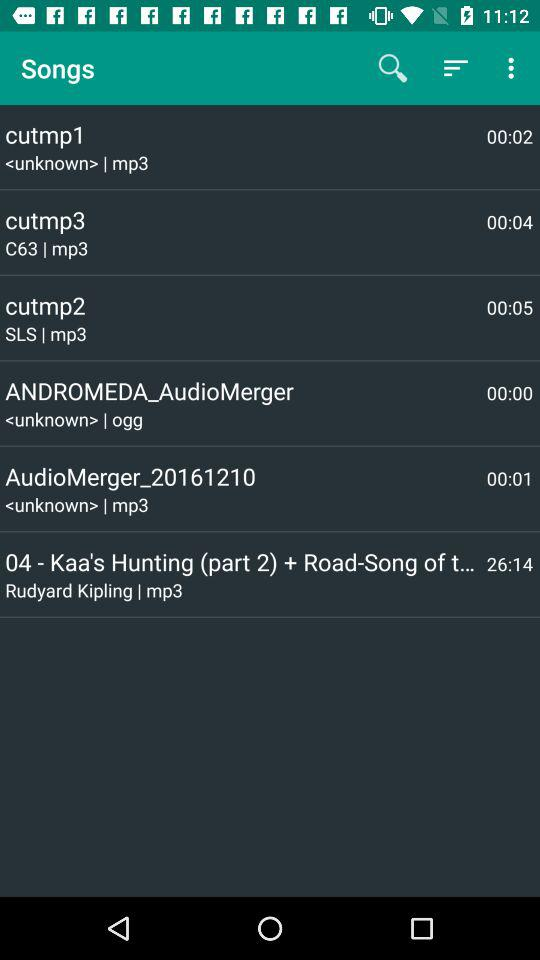What is the duration of the cutmp1 song? The duration is 00:02. 